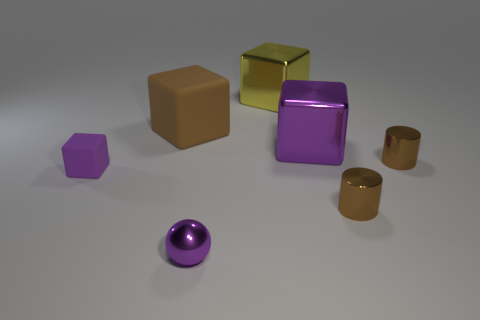Are there any other things that have the same shape as the small purple metal thing?
Your answer should be very brief. No. Does the big cube that is left of the shiny sphere have the same color as the small object that is behind the tiny purple rubber object?
Your response must be concise. Yes. What is the material of the large block on the left side of the large yellow thing to the left of the tiny cylinder behind the small purple cube?
Give a very brief answer. Rubber. Are there any other shiny objects that have the same size as the yellow object?
Give a very brief answer. Yes. There is a block that is the same size as the purple metal sphere; what material is it?
Keep it short and to the point. Rubber. What shape is the brown thing behind the large purple metallic object?
Provide a succinct answer. Cube. Is the material of the big cube that is left of the tiny sphere the same as the purple cube left of the large yellow metallic block?
Offer a terse response. Yes. How many large rubber objects are the same shape as the small rubber thing?
Your answer should be compact. 1. What is the material of the big block that is the same color as the metal sphere?
Your answer should be compact. Metal. How many things are big purple shiny things or purple shiny things behind the small purple metal thing?
Make the answer very short. 1. 